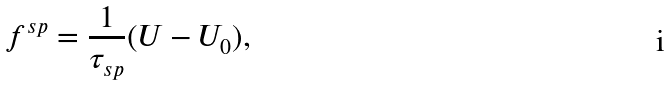Convert formula to latex. <formula><loc_0><loc_0><loc_500><loc_500>f ^ { s p } = \frac { 1 } { \tau _ { s p } } ( U - U _ { 0 } ) ,</formula> 